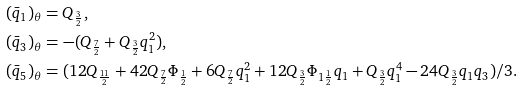Convert formula to latex. <formula><loc_0><loc_0><loc_500><loc_500>( { \bar { q } _ { 1 } } ) _ { \theta } & = Q _ { \frac { 3 } { 2 } } , \\ ( { \bar { q } _ { 3 } } ) _ { \theta } & = - ( Q _ { \frac { 7 } { 2 } } + Q _ { \frac { 3 } { 2 } } q _ { 1 } ^ { 2 } ) , \\ ( { \bar { q } _ { 5 } } ) _ { \theta } & = ( 1 2 Q _ { \frac { 1 1 } { 2 } } + 4 2 Q _ { \frac { 7 } { 2 } } \Phi _ { \frac { 1 } { 2 } } + 6 Q _ { \frac { 7 } { 2 } } q _ { 1 } ^ { 2 } + 1 2 Q _ { \frac { 3 } { 2 } } \Phi _ { 1 \frac { 1 } { 2 } } q _ { 1 } + Q _ { \frac { 3 } { 2 } } q _ { 1 } ^ { 4 } - 2 4 Q _ { \frac { 3 } { 2 } } q _ { 1 } q _ { 3 } ) / 3 .</formula> 